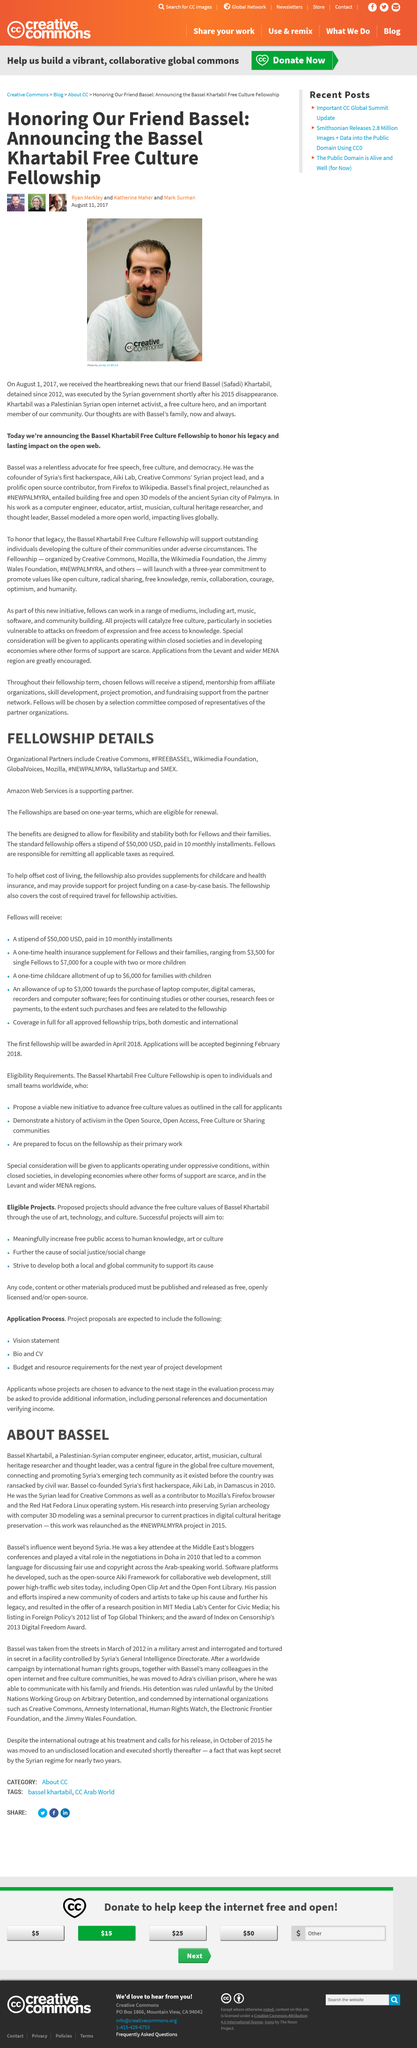Give some essential details in this illustration. In 2015, Bassets work was relaunched as the #NEWPALMYRA project. Bassel Khartabil is a Syrian computer engineer, educator, artist, musician, cultural heritage researcher and thought leader who is known for his various contributions to society. Bassel Safadi Khartabil was photographed by Joi Ito. Bassel was executed shortly after his disappearance in 2015. The authors of this article are Ryan Merkley, Katherine Maher, and Mark Surman. 